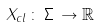<formula> <loc_0><loc_0><loc_500><loc_500>X _ { c l } \, \colon \, \Sigma \, \rightarrow \mathbb { R }</formula> 